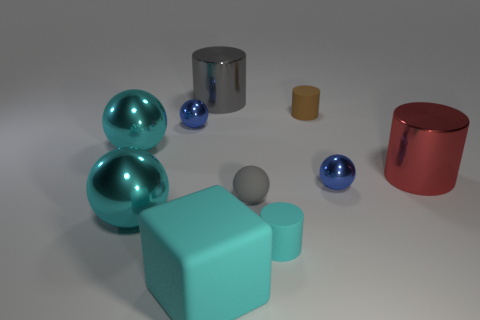Describe the possible materials the objects are made of. The objects in the image appear to be made of different materials; some exhibit a metallic sheen suggesting a reflective, possibly metallic substance, while others possess a matte finish which might indicate a plastic or ceramic composition. What clues suggest those materials? The reflective qualities and the way light bends and reflects off the surfaces of the metallic objects are indicative of metal, while the uniform and non-reflective surfaces of the matte objects suggest less shiny materials like plastic or ceramic. 